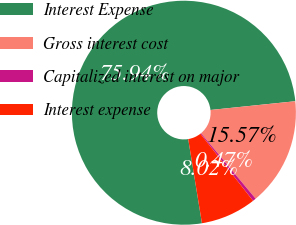Convert chart. <chart><loc_0><loc_0><loc_500><loc_500><pie_chart><fcel>Interest Expense<fcel>Gross interest cost<fcel>Capitalized interest on major<fcel>Interest expense<nl><fcel>75.94%<fcel>15.57%<fcel>0.47%<fcel>8.02%<nl></chart> 